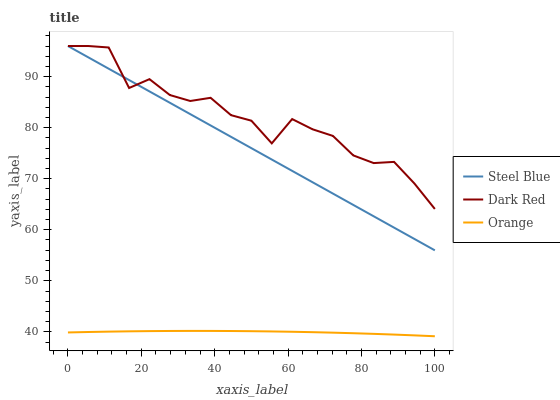Does Orange have the minimum area under the curve?
Answer yes or no. Yes. Does Dark Red have the maximum area under the curve?
Answer yes or no. Yes. Does Steel Blue have the minimum area under the curve?
Answer yes or no. No. Does Steel Blue have the maximum area under the curve?
Answer yes or no. No. Is Steel Blue the smoothest?
Answer yes or no. Yes. Is Dark Red the roughest?
Answer yes or no. Yes. Is Dark Red the smoothest?
Answer yes or no. No. Is Steel Blue the roughest?
Answer yes or no. No. Does Steel Blue have the lowest value?
Answer yes or no. No. Does Steel Blue have the highest value?
Answer yes or no. Yes. Is Orange less than Dark Red?
Answer yes or no. Yes. Is Dark Red greater than Orange?
Answer yes or no. Yes. Does Orange intersect Dark Red?
Answer yes or no. No. 